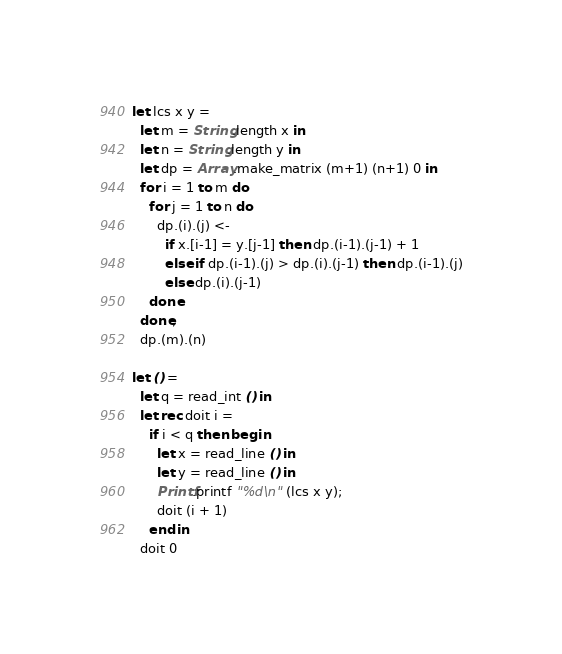<code> <loc_0><loc_0><loc_500><loc_500><_OCaml_>let lcs x y =
  let m = String.length x in
  let n = String.length y in
  let dp = Array.make_matrix (m+1) (n+1) 0 in
  for i = 1 to m do
    for j = 1 to n do
      dp.(i).(j) <-
        if x.[i-1] = y.[j-1] then dp.(i-1).(j-1) + 1
        else if dp.(i-1).(j) > dp.(i).(j-1) then dp.(i-1).(j)
        else dp.(i).(j-1)
    done
  done;
  dp.(m).(n)

let () =
  let q = read_int () in
  let rec doit i =
    if i < q then begin
      let x = read_line () in
      let y = read_line () in
      Printf.printf "%d\n" (lcs x y);
      doit (i + 1)
    end in
  doit 0</code> 